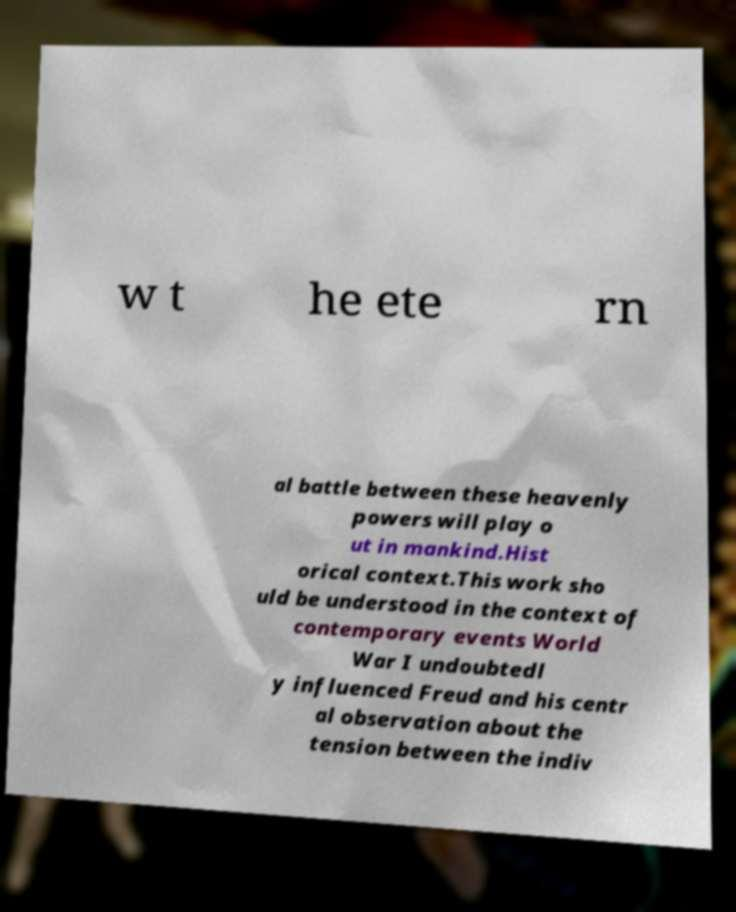Could you assist in decoding the text presented in this image and type it out clearly? w t he ete rn al battle between these heavenly powers will play o ut in mankind.Hist orical context.This work sho uld be understood in the context of contemporary events World War I undoubtedl y influenced Freud and his centr al observation about the tension between the indiv 